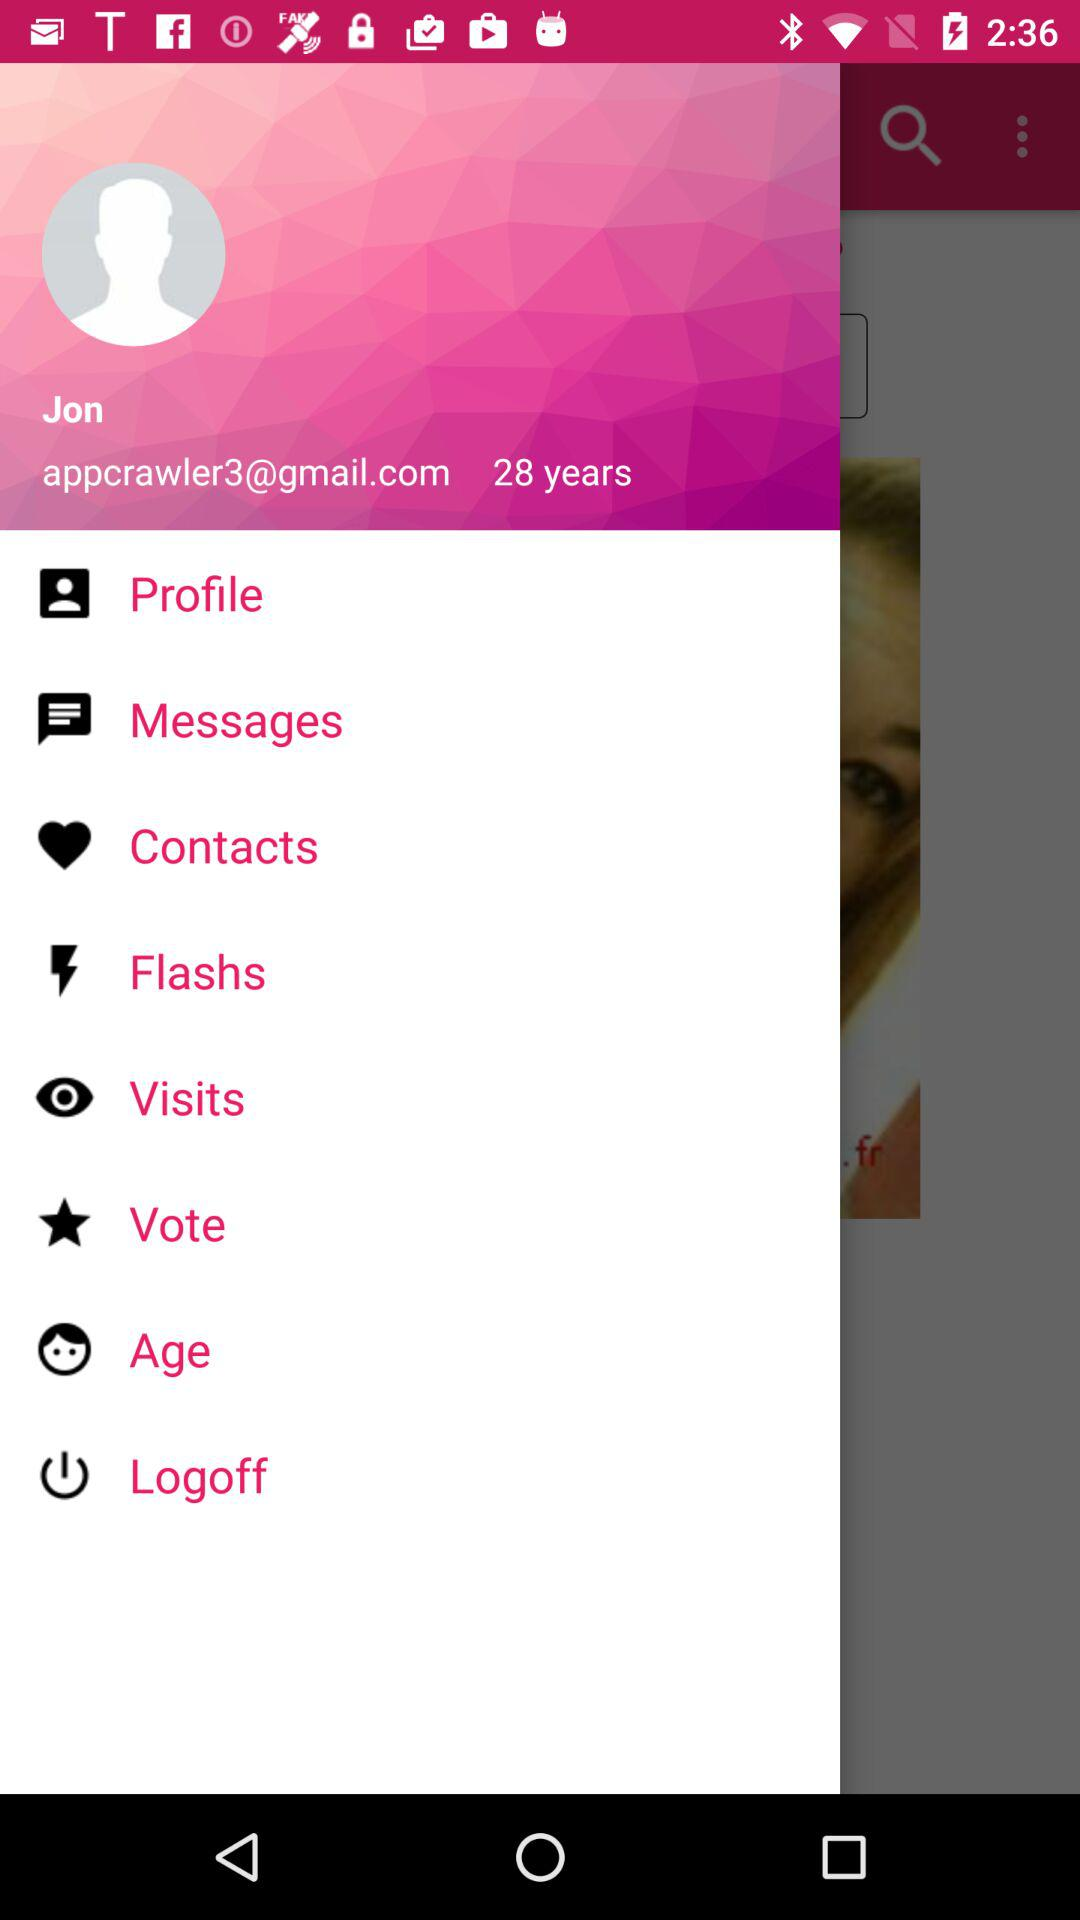What is the name of the user? The name of the user is Jon. 